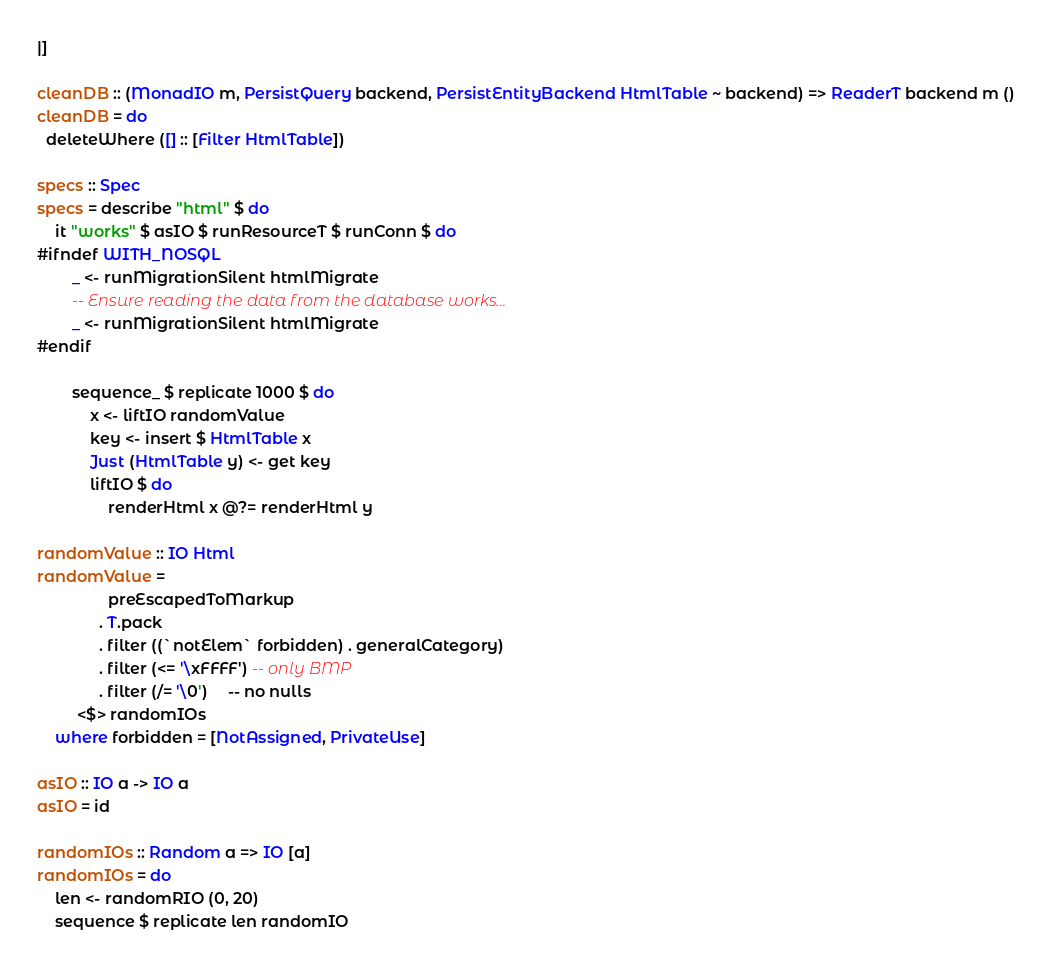Convert code to text. <code><loc_0><loc_0><loc_500><loc_500><_Haskell_>|]

cleanDB :: (MonadIO m, PersistQuery backend, PersistEntityBackend HtmlTable ~ backend) => ReaderT backend m ()
cleanDB = do
  deleteWhere ([] :: [Filter HtmlTable])

specs :: Spec
specs = describe "html" $ do
    it "works" $ asIO $ runResourceT $ runConn $ do
#ifndef WITH_NOSQL
        _ <- runMigrationSilent htmlMigrate
        -- Ensure reading the data from the database works...
        _ <- runMigrationSilent htmlMigrate
#endif

        sequence_ $ replicate 1000 $ do
            x <- liftIO randomValue
            key <- insert $ HtmlTable x
            Just (HtmlTable y) <- get key
            liftIO $ do
                renderHtml x @?= renderHtml y

randomValue :: IO Html
randomValue =
                preEscapedToMarkup
              . T.pack
              . filter ((`notElem` forbidden) . generalCategory)
              . filter (<= '\xFFFF') -- only BMP
              . filter (/= '\0')     -- no nulls
         <$> randomIOs
    where forbidden = [NotAssigned, PrivateUse]

asIO :: IO a -> IO a
asIO = id

randomIOs :: Random a => IO [a]
randomIOs = do
    len <- randomRIO (0, 20)
    sequence $ replicate len randomIO
</code> 